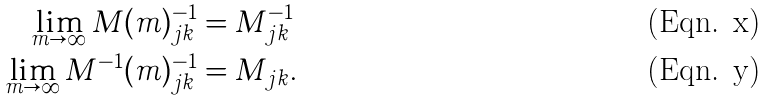<formula> <loc_0><loc_0><loc_500><loc_500>\lim _ { m \to \infty } M ( m ) ^ { - 1 } _ { j k } & = M ^ { - 1 } _ { j k } \\ \lim _ { m \to \infty } M ^ { - 1 } ( m ) ^ { - 1 } _ { j k } & = M _ { j k } .</formula> 